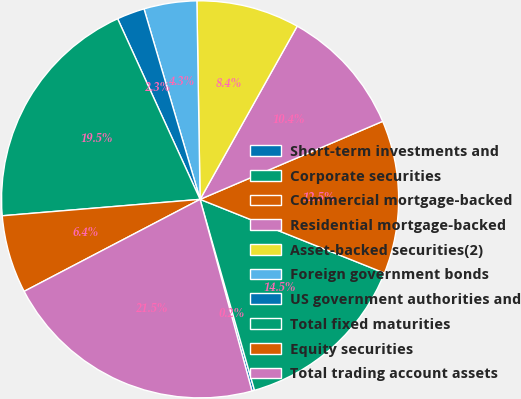Convert chart to OTSL. <chart><loc_0><loc_0><loc_500><loc_500><pie_chart><fcel>Short-term investments and<fcel>Corporate securities<fcel>Commercial mortgage-backed<fcel>Residential mortgage-backed<fcel>Asset-backed securities(2)<fcel>Foreign government bonds<fcel>US government authorities and<fcel>Total fixed maturities<fcel>Equity securities<fcel>Total trading account assets<nl><fcel>0.21%<fcel>14.53%<fcel>12.48%<fcel>10.44%<fcel>8.39%<fcel>4.3%<fcel>2.26%<fcel>19.5%<fcel>6.35%<fcel>21.54%<nl></chart> 